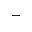<formula> <loc_0><loc_0><loc_500><loc_500>-</formula> 